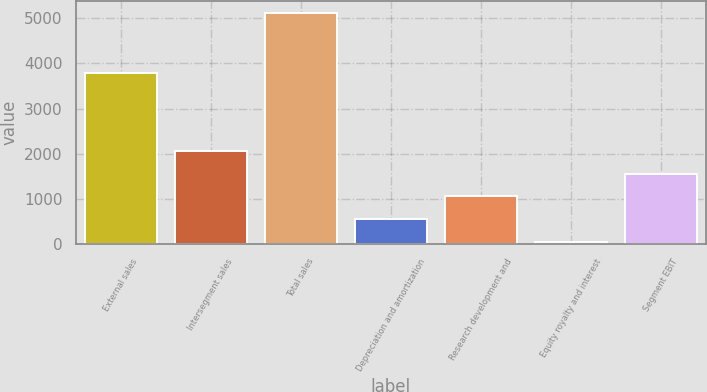Convert chart. <chart><loc_0><loc_0><loc_500><loc_500><bar_chart><fcel>External sales<fcel>Intersegment sales<fcel>Total sales<fcel>Depreciation and amortization<fcel>Research development and<fcel>Equity royalty and interest<fcel>Segment EBIT<nl><fcel>3791<fcel>2068.8<fcel>5118<fcel>544.2<fcel>1052.4<fcel>36<fcel>1560.6<nl></chart> 